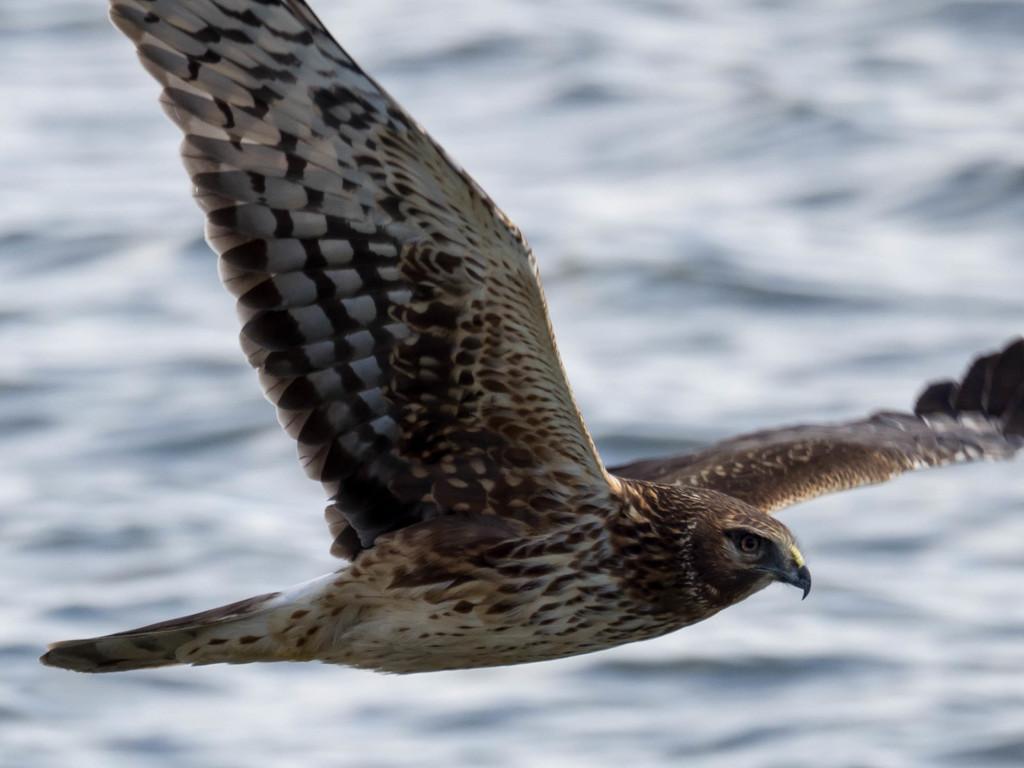Describe this image in one or two sentences. In this image we can see a bird is flying in the air. 